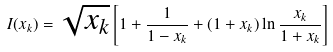<formula> <loc_0><loc_0><loc_500><loc_500>I ( x _ { k } ) = \sqrt { x _ { k } } \left [ 1 + \frac { 1 } { 1 - x _ { k } } + ( 1 + x _ { k } ) \ln \frac { x _ { k } } { 1 + x _ { k } } \right ]</formula> 